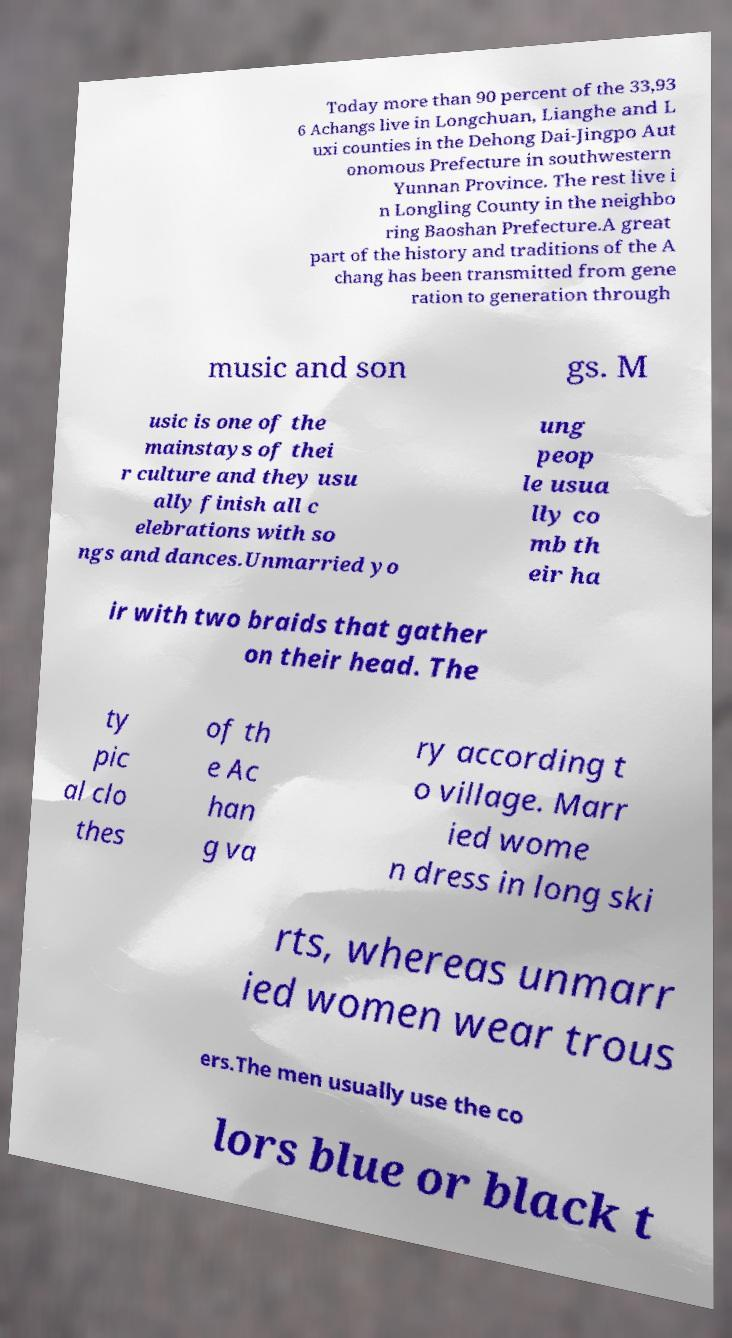Please identify and transcribe the text found in this image. Today more than 90 percent of the 33,93 6 Achangs live in Longchuan, Lianghe and L uxi counties in the Dehong Dai-Jingpo Aut onomous Prefecture in southwestern Yunnan Province. The rest live i n Longling County in the neighbo ring Baoshan Prefecture.A great part of the history and traditions of the A chang has been transmitted from gene ration to generation through music and son gs. M usic is one of the mainstays of thei r culture and they usu ally finish all c elebrations with so ngs and dances.Unmarried yo ung peop le usua lly co mb th eir ha ir with two braids that gather on their head. The ty pic al clo thes of th e Ac han g va ry according t o village. Marr ied wome n dress in long ski rts, whereas unmarr ied women wear trous ers.The men usually use the co lors blue or black t 